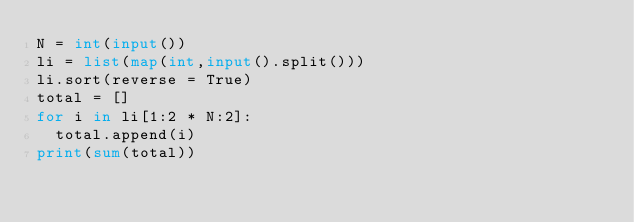<code> <loc_0><loc_0><loc_500><loc_500><_Python_>N = int(input())
li = list(map(int,input().split()))
li.sort(reverse = True)
total = []
for i in li[1:2 * N:2]:
  total.append(i)
print(sum(total))</code> 